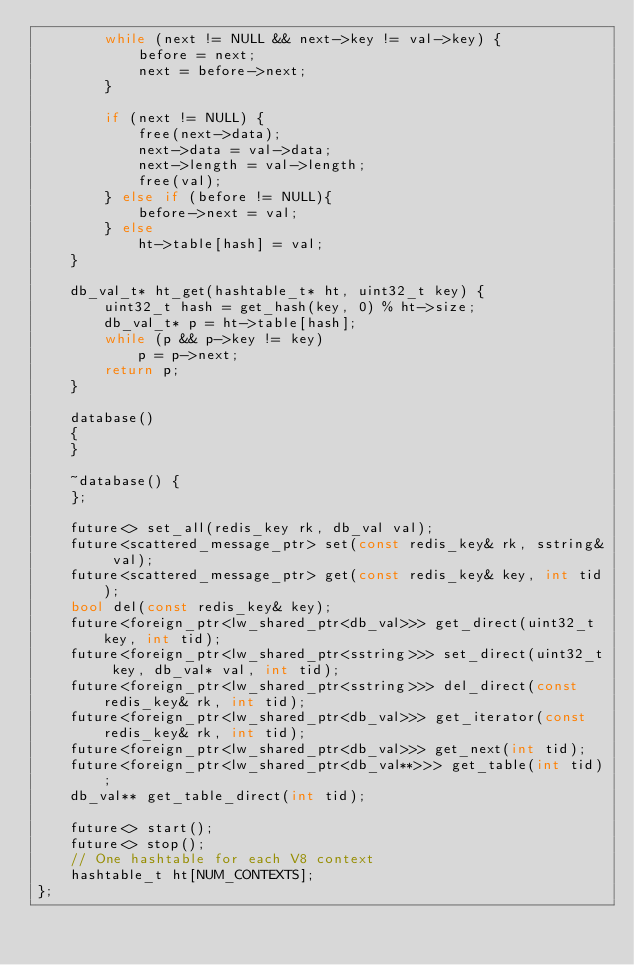Convert code to text. <code><loc_0><loc_0><loc_500><loc_500><_C++_>        while (next != NULL && next->key != val->key) {
            before = next;
            next = before->next;
        }

        if (next != NULL) {
            free(next->data);
            next->data = val->data;
            next->length = val->length;
            free(val);
        } else if (before != NULL){
            before->next = val;
        } else
            ht->table[hash] = val;
    }

    db_val_t* ht_get(hashtable_t* ht, uint32_t key) {
        uint32_t hash = get_hash(key, 0) % ht->size;
        db_val_t* p = ht->table[hash];
        while (p && p->key != key)
            p = p->next;
        return p;
    }

    database()
    {
    }

    ~database() {
    }; 

    future<> set_all(redis_key rk, db_val val);
    future<scattered_message_ptr> set(const redis_key& rk, sstring& val);
    future<scattered_message_ptr> get(const redis_key& key, int tid);
    bool del(const redis_key& key);
    future<foreign_ptr<lw_shared_ptr<db_val>>> get_direct(uint32_t key, int tid);
    future<foreign_ptr<lw_shared_ptr<sstring>>> set_direct(uint32_t key, db_val* val, int tid);
    future<foreign_ptr<lw_shared_ptr<sstring>>> del_direct(const redis_key& rk, int tid);
    future<foreign_ptr<lw_shared_ptr<db_val>>> get_iterator(const redis_key& rk, int tid);
    future<foreign_ptr<lw_shared_ptr<db_val>>> get_next(int tid);
    future<foreign_ptr<lw_shared_ptr<db_val**>>> get_table(int tid);
    db_val** get_table_direct(int tid);

    future<> start();
    future<> stop();
    // One hashtable for each V8 context
    hashtable_t ht[NUM_CONTEXTS];
};
</code> 